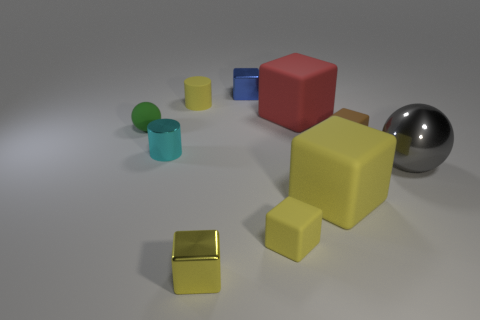What is the color of the cylinder that is the same material as the large red cube? The cylinder that shares the same matte material as the large red cube is blue. 